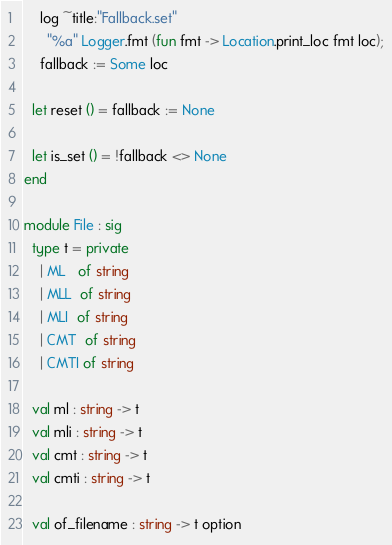Convert code to text. <code><loc_0><loc_0><loc_500><loc_500><_OCaml_>    log ~title:"Fallback.set"
      "%a" Logger.fmt (fun fmt -> Location.print_loc fmt loc);
    fallback := Some loc

  let reset () = fallback := None

  let is_set () = !fallback <> None
end

module File : sig
  type t = private
    | ML   of string
    | MLL  of string
    | MLI  of string
    | CMT  of string
    | CMTI of string

  val ml : string -> t
  val mli : string -> t
  val cmt : string -> t
  val cmti : string -> t

  val of_filename : string -> t option
</code> 